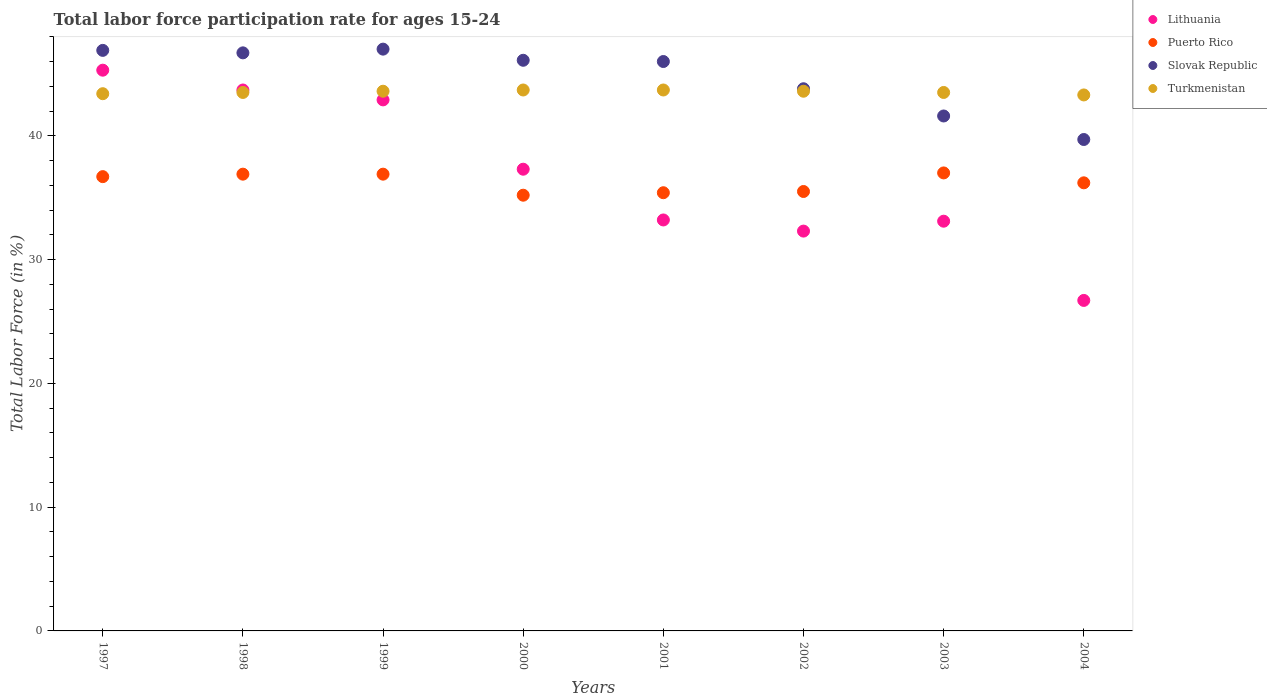Is the number of dotlines equal to the number of legend labels?
Your answer should be compact. Yes. What is the labor force participation rate in Lithuania in 2002?
Your response must be concise. 32.3. Across all years, what is the maximum labor force participation rate in Slovak Republic?
Your response must be concise. 47. Across all years, what is the minimum labor force participation rate in Puerto Rico?
Provide a short and direct response. 35.2. What is the total labor force participation rate in Lithuania in the graph?
Your response must be concise. 294.5. What is the difference between the labor force participation rate in Puerto Rico in 2000 and that in 2001?
Keep it short and to the point. -0.2. What is the average labor force participation rate in Slovak Republic per year?
Offer a terse response. 44.72. In the year 2001, what is the difference between the labor force participation rate in Slovak Republic and labor force participation rate in Lithuania?
Make the answer very short. 12.8. In how many years, is the labor force participation rate in Puerto Rico greater than 30 %?
Give a very brief answer. 8. What is the ratio of the labor force participation rate in Turkmenistan in 1997 to that in 2003?
Make the answer very short. 1. Is the labor force participation rate in Turkmenistan in 1999 less than that in 2002?
Your answer should be very brief. No. Is the difference between the labor force participation rate in Slovak Republic in 2002 and 2004 greater than the difference between the labor force participation rate in Lithuania in 2002 and 2004?
Provide a succinct answer. No. What is the difference between the highest and the second highest labor force participation rate in Puerto Rico?
Your response must be concise. 0.1. What is the difference between the highest and the lowest labor force participation rate in Lithuania?
Offer a very short reply. 18.6. Is the sum of the labor force participation rate in Puerto Rico in 1997 and 1999 greater than the maximum labor force participation rate in Lithuania across all years?
Your response must be concise. Yes. Is it the case that in every year, the sum of the labor force participation rate in Turkmenistan and labor force participation rate in Puerto Rico  is greater than the labor force participation rate in Lithuania?
Keep it short and to the point. Yes. Does the labor force participation rate in Slovak Republic monotonically increase over the years?
Ensure brevity in your answer.  No. Is the labor force participation rate in Slovak Republic strictly greater than the labor force participation rate in Puerto Rico over the years?
Your answer should be very brief. Yes. Is the labor force participation rate in Puerto Rico strictly less than the labor force participation rate in Turkmenistan over the years?
Provide a short and direct response. Yes. How many dotlines are there?
Make the answer very short. 4. Are the values on the major ticks of Y-axis written in scientific E-notation?
Make the answer very short. No. Does the graph contain any zero values?
Provide a succinct answer. No. How are the legend labels stacked?
Your response must be concise. Vertical. What is the title of the graph?
Keep it short and to the point. Total labor force participation rate for ages 15-24. Does "Georgia" appear as one of the legend labels in the graph?
Provide a short and direct response. No. What is the label or title of the Y-axis?
Provide a short and direct response. Total Labor Force (in %). What is the Total Labor Force (in %) of Lithuania in 1997?
Keep it short and to the point. 45.3. What is the Total Labor Force (in %) of Puerto Rico in 1997?
Offer a very short reply. 36.7. What is the Total Labor Force (in %) in Slovak Republic in 1997?
Offer a very short reply. 46.9. What is the Total Labor Force (in %) in Turkmenistan in 1997?
Offer a terse response. 43.4. What is the Total Labor Force (in %) in Lithuania in 1998?
Provide a short and direct response. 43.7. What is the Total Labor Force (in %) of Puerto Rico in 1998?
Offer a terse response. 36.9. What is the Total Labor Force (in %) of Slovak Republic in 1998?
Ensure brevity in your answer.  46.7. What is the Total Labor Force (in %) in Turkmenistan in 1998?
Your answer should be very brief. 43.5. What is the Total Labor Force (in %) of Lithuania in 1999?
Keep it short and to the point. 42.9. What is the Total Labor Force (in %) in Puerto Rico in 1999?
Offer a very short reply. 36.9. What is the Total Labor Force (in %) in Slovak Republic in 1999?
Your answer should be very brief. 47. What is the Total Labor Force (in %) of Turkmenistan in 1999?
Make the answer very short. 43.6. What is the Total Labor Force (in %) in Lithuania in 2000?
Give a very brief answer. 37.3. What is the Total Labor Force (in %) in Puerto Rico in 2000?
Provide a succinct answer. 35.2. What is the Total Labor Force (in %) in Slovak Republic in 2000?
Provide a succinct answer. 46.1. What is the Total Labor Force (in %) of Turkmenistan in 2000?
Offer a very short reply. 43.7. What is the Total Labor Force (in %) of Lithuania in 2001?
Your answer should be compact. 33.2. What is the Total Labor Force (in %) of Puerto Rico in 2001?
Ensure brevity in your answer.  35.4. What is the Total Labor Force (in %) in Slovak Republic in 2001?
Offer a terse response. 46. What is the Total Labor Force (in %) of Turkmenistan in 2001?
Your response must be concise. 43.7. What is the Total Labor Force (in %) in Lithuania in 2002?
Make the answer very short. 32.3. What is the Total Labor Force (in %) in Puerto Rico in 2002?
Keep it short and to the point. 35.5. What is the Total Labor Force (in %) of Slovak Republic in 2002?
Provide a succinct answer. 43.8. What is the Total Labor Force (in %) in Turkmenistan in 2002?
Offer a terse response. 43.6. What is the Total Labor Force (in %) in Lithuania in 2003?
Your answer should be compact. 33.1. What is the Total Labor Force (in %) of Puerto Rico in 2003?
Offer a terse response. 37. What is the Total Labor Force (in %) in Slovak Republic in 2003?
Offer a very short reply. 41.6. What is the Total Labor Force (in %) in Turkmenistan in 2003?
Ensure brevity in your answer.  43.5. What is the Total Labor Force (in %) in Lithuania in 2004?
Ensure brevity in your answer.  26.7. What is the Total Labor Force (in %) of Puerto Rico in 2004?
Ensure brevity in your answer.  36.2. What is the Total Labor Force (in %) in Slovak Republic in 2004?
Ensure brevity in your answer.  39.7. What is the Total Labor Force (in %) of Turkmenistan in 2004?
Provide a short and direct response. 43.3. Across all years, what is the maximum Total Labor Force (in %) of Lithuania?
Ensure brevity in your answer.  45.3. Across all years, what is the maximum Total Labor Force (in %) of Slovak Republic?
Ensure brevity in your answer.  47. Across all years, what is the maximum Total Labor Force (in %) of Turkmenistan?
Offer a very short reply. 43.7. Across all years, what is the minimum Total Labor Force (in %) in Lithuania?
Ensure brevity in your answer.  26.7. Across all years, what is the minimum Total Labor Force (in %) of Puerto Rico?
Offer a terse response. 35.2. Across all years, what is the minimum Total Labor Force (in %) of Slovak Republic?
Give a very brief answer. 39.7. Across all years, what is the minimum Total Labor Force (in %) of Turkmenistan?
Provide a short and direct response. 43.3. What is the total Total Labor Force (in %) in Lithuania in the graph?
Provide a succinct answer. 294.5. What is the total Total Labor Force (in %) in Puerto Rico in the graph?
Your answer should be very brief. 289.8. What is the total Total Labor Force (in %) in Slovak Republic in the graph?
Ensure brevity in your answer.  357.8. What is the total Total Labor Force (in %) of Turkmenistan in the graph?
Make the answer very short. 348.3. What is the difference between the Total Labor Force (in %) in Lithuania in 1997 and that in 1998?
Your answer should be compact. 1.6. What is the difference between the Total Labor Force (in %) in Slovak Republic in 1997 and that in 1998?
Provide a short and direct response. 0.2. What is the difference between the Total Labor Force (in %) of Lithuania in 1997 and that in 1999?
Give a very brief answer. 2.4. What is the difference between the Total Labor Force (in %) in Puerto Rico in 1997 and that in 1999?
Keep it short and to the point. -0.2. What is the difference between the Total Labor Force (in %) in Lithuania in 1997 and that in 2000?
Your response must be concise. 8. What is the difference between the Total Labor Force (in %) in Puerto Rico in 1997 and that in 2000?
Give a very brief answer. 1.5. What is the difference between the Total Labor Force (in %) of Turkmenistan in 1997 and that in 2000?
Offer a very short reply. -0.3. What is the difference between the Total Labor Force (in %) of Slovak Republic in 1997 and that in 2001?
Ensure brevity in your answer.  0.9. What is the difference between the Total Labor Force (in %) in Slovak Republic in 1997 and that in 2002?
Provide a short and direct response. 3.1. What is the difference between the Total Labor Force (in %) of Lithuania in 1997 and that in 2003?
Provide a short and direct response. 12.2. What is the difference between the Total Labor Force (in %) of Slovak Republic in 1997 and that in 2003?
Keep it short and to the point. 5.3. What is the difference between the Total Labor Force (in %) of Turkmenistan in 1997 and that in 2003?
Make the answer very short. -0.1. What is the difference between the Total Labor Force (in %) in Puerto Rico in 1997 and that in 2004?
Your answer should be very brief. 0.5. What is the difference between the Total Labor Force (in %) in Puerto Rico in 1998 and that in 1999?
Your answer should be compact. 0. What is the difference between the Total Labor Force (in %) of Slovak Republic in 1998 and that in 2000?
Your answer should be very brief. 0.6. What is the difference between the Total Labor Force (in %) of Turkmenistan in 1998 and that in 2001?
Offer a very short reply. -0.2. What is the difference between the Total Labor Force (in %) in Slovak Republic in 1998 and that in 2002?
Your answer should be compact. 2.9. What is the difference between the Total Labor Force (in %) of Puerto Rico in 1998 and that in 2003?
Make the answer very short. -0.1. What is the difference between the Total Labor Force (in %) of Slovak Republic in 1998 and that in 2003?
Make the answer very short. 5.1. What is the difference between the Total Labor Force (in %) of Lithuania in 1998 and that in 2004?
Provide a short and direct response. 17. What is the difference between the Total Labor Force (in %) of Slovak Republic in 1998 and that in 2004?
Ensure brevity in your answer.  7. What is the difference between the Total Labor Force (in %) in Turkmenistan in 1998 and that in 2004?
Provide a short and direct response. 0.2. What is the difference between the Total Labor Force (in %) of Puerto Rico in 1999 and that in 2000?
Provide a short and direct response. 1.7. What is the difference between the Total Labor Force (in %) of Slovak Republic in 1999 and that in 2000?
Your response must be concise. 0.9. What is the difference between the Total Labor Force (in %) of Puerto Rico in 1999 and that in 2001?
Offer a very short reply. 1.5. What is the difference between the Total Labor Force (in %) of Puerto Rico in 1999 and that in 2002?
Ensure brevity in your answer.  1.4. What is the difference between the Total Labor Force (in %) of Slovak Republic in 1999 and that in 2002?
Your answer should be very brief. 3.2. What is the difference between the Total Labor Force (in %) in Turkmenistan in 1999 and that in 2002?
Provide a short and direct response. 0. What is the difference between the Total Labor Force (in %) in Lithuania in 1999 and that in 2004?
Offer a very short reply. 16.2. What is the difference between the Total Labor Force (in %) of Turkmenistan in 2000 and that in 2001?
Your answer should be compact. 0. What is the difference between the Total Labor Force (in %) of Lithuania in 2000 and that in 2003?
Offer a very short reply. 4.2. What is the difference between the Total Labor Force (in %) in Slovak Republic in 2000 and that in 2003?
Offer a terse response. 4.5. What is the difference between the Total Labor Force (in %) of Turkmenistan in 2000 and that in 2003?
Your answer should be very brief. 0.2. What is the difference between the Total Labor Force (in %) of Slovak Republic in 2000 and that in 2004?
Offer a very short reply. 6.4. What is the difference between the Total Labor Force (in %) of Puerto Rico in 2001 and that in 2002?
Give a very brief answer. -0.1. What is the difference between the Total Labor Force (in %) of Slovak Republic in 2001 and that in 2002?
Offer a terse response. 2.2. What is the difference between the Total Labor Force (in %) in Turkmenistan in 2001 and that in 2002?
Offer a very short reply. 0.1. What is the difference between the Total Labor Force (in %) of Turkmenistan in 2001 and that in 2003?
Your answer should be very brief. 0.2. What is the difference between the Total Labor Force (in %) of Lithuania in 2001 and that in 2004?
Keep it short and to the point. 6.5. What is the difference between the Total Labor Force (in %) in Turkmenistan in 2001 and that in 2004?
Your answer should be very brief. 0.4. What is the difference between the Total Labor Force (in %) in Slovak Republic in 2002 and that in 2004?
Offer a terse response. 4.1. What is the difference between the Total Labor Force (in %) in Turkmenistan in 2002 and that in 2004?
Provide a succinct answer. 0.3. What is the difference between the Total Labor Force (in %) in Lithuania in 2003 and that in 2004?
Offer a very short reply. 6.4. What is the difference between the Total Labor Force (in %) of Slovak Republic in 2003 and that in 2004?
Keep it short and to the point. 1.9. What is the difference between the Total Labor Force (in %) in Turkmenistan in 2003 and that in 2004?
Offer a terse response. 0.2. What is the difference between the Total Labor Force (in %) of Lithuania in 1997 and the Total Labor Force (in %) of Puerto Rico in 1998?
Give a very brief answer. 8.4. What is the difference between the Total Labor Force (in %) of Lithuania in 1997 and the Total Labor Force (in %) of Puerto Rico in 1999?
Offer a terse response. 8.4. What is the difference between the Total Labor Force (in %) in Lithuania in 1997 and the Total Labor Force (in %) in Slovak Republic in 1999?
Ensure brevity in your answer.  -1.7. What is the difference between the Total Labor Force (in %) in Puerto Rico in 1997 and the Total Labor Force (in %) in Turkmenistan in 1999?
Ensure brevity in your answer.  -6.9. What is the difference between the Total Labor Force (in %) of Lithuania in 1997 and the Total Labor Force (in %) of Turkmenistan in 2000?
Your answer should be compact. 1.6. What is the difference between the Total Labor Force (in %) in Puerto Rico in 1997 and the Total Labor Force (in %) in Turkmenistan in 2000?
Make the answer very short. -7. What is the difference between the Total Labor Force (in %) in Slovak Republic in 1997 and the Total Labor Force (in %) in Turkmenistan in 2000?
Keep it short and to the point. 3.2. What is the difference between the Total Labor Force (in %) of Lithuania in 1997 and the Total Labor Force (in %) of Slovak Republic in 2001?
Provide a short and direct response. -0.7. What is the difference between the Total Labor Force (in %) in Lithuania in 1997 and the Total Labor Force (in %) in Turkmenistan in 2001?
Provide a succinct answer. 1.6. What is the difference between the Total Labor Force (in %) in Slovak Republic in 1997 and the Total Labor Force (in %) in Turkmenistan in 2002?
Provide a succinct answer. 3.3. What is the difference between the Total Labor Force (in %) in Lithuania in 1997 and the Total Labor Force (in %) in Puerto Rico in 2003?
Provide a short and direct response. 8.3. What is the difference between the Total Labor Force (in %) of Lithuania in 1997 and the Total Labor Force (in %) of Slovak Republic in 2003?
Ensure brevity in your answer.  3.7. What is the difference between the Total Labor Force (in %) of Puerto Rico in 1997 and the Total Labor Force (in %) of Slovak Republic in 2003?
Provide a succinct answer. -4.9. What is the difference between the Total Labor Force (in %) in Slovak Republic in 1997 and the Total Labor Force (in %) in Turkmenistan in 2003?
Ensure brevity in your answer.  3.4. What is the difference between the Total Labor Force (in %) in Lithuania in 1997 and the Total Labor Force (in %) in Slovak Republic in 2004?
Your answer should be compact. 5.6. What is the difference between the Total Labor Force (in %) of Lithuania in 1997 and the Total Labor Force (in %) of Turkmenistan in 2004?
Your response must be concise. 2. What is the difference between the Total Labor Force (in %) in Slovak Republic in 1997 and the Total Labor Force (in %) in Turkmenistan in 2004?
Ensure brevity in your answer.  3.6. What is the difference between the Total Labor Force (in %) of Lithuania in 1998 and the Total Labor Force (in %) of Puerto Rico in 1999?
Keep it short and to the point. 6.8. What is the difference between the Total Labor Force (in %) of Lithuania in 1998 and the Total Labor Force (in %) of Turkmenistan in 1999?
Keep it short and to the point. 0.1. What is the difference between the Total Labor Force (in %) of Lithuania in 1998 and the Total Labor Force (in %) of Puerto Rico in 2000?
Your answer should be very brief. 8.5. What is the difference between the Total Labor Force (in %) in Lithuania in 1998 and the Total Labor Force (in %) in Turkmenistan in 2000?
Keep it short and to the point. 0. What is the difference between the Total Labor Force (in %) in Puerto Rico in 1998 and the Total Labor Force (in %) in Slovak Republic in 2000?
Give a very brief answer. -9.2. What is the difference between the Total Labor Force (in %) in Puerto Rico in 1998 and the Total Labor Force (in %) in Turkmenistan in 2000?
Offer a very short reply. -6.8. What is the difference between the Total Labor Force (in %) of Slovak Republic in 1998 and the Total Labor Force (in %) of Turkmenistan in 2000?
Your answer should be very brief. 3. What is the difference between the Total Labor Force (in %) of Lithuania in 1998 and the Total Labor Force (in %) of Puerto Rico in 2001?
Provide a succinct answer. 8.3. What is the difference between the Total Labor Force (in %) of Lithuania in 1998 and the Total Labor Force (in %) of Slovak Republic in 2001?
Offer a very short reply. -2.3. What is the difference between the Total Labor Force (in %) of Lithuania in 1998 and the Total Labor Force (in %) of Turkmenistan in 2001?
Your response must be concise. 0. What is the difference between the Total Labor Force (in %) in Lithuania in 1998 and the Total Labor Force (in %) in Puerto Rico in 2002?
Offer a very short reply. 8.2. What is the difference between the Total Labor Force (in %) in Lithuania in 1998 and the Total Labor Force (in %) in Slovak Republic in 2002?
Ensure brevity in your answer.  -0.1. What is the difference between the Total Labor Force (in %) of Puerto Rico in 1998 and the Total Labor Force (in %) of Slovak Republic in 2002?
Provide a succinct answer. -6.9. What is the difference between the Total Labor Force (in %) in Puerto Rico in 1998 and the Total Labor Force (in %) in Turkmenistan in 2002?
Ensure brevity in your answer.  -6.7. What is the difference between the Total Labor Force (in %) in Lithuania in 1998 and the Total Labor Force (in %) in Slovak Republic in 2003?
Offer a very short reply. 2.1. What is the difference between the Total Labor Force (in %) in Puerto Rico in 1998 and the Total Labor Force (in %) in Slovak Republic in 2003?
Offer a terse response. -4.7. What is the difference between the Total Labor Force (in %) of Slovak Republic in 1998 and the Total Labor Force (in %) of Turkmenistan in 2003?
Keep it short and to the point. 3.2. What is the difference between the Total Labor Force (in %) in Lithuania in 1998 and the Total Labor Force (in %) in Turkmenistan in 2004?
Give a very brief answer. 0.4. What is the difference between the Total Labor Force (in %) of Lithuania in 1999 and the Total Labor Force (in %) of Slovak Republic in 2000?
Provide a succinct answer. -3.2. What is the difference between the Total Labor Force (in %) of Lithuania in 1999 and the Total Labor Force (in %) of Turkmenistan in 2000?
Provide a succinct answer. -0.8. What is the difference between the Total Labor Force (in %) in Puerto Rico in 1999 and the Total Labor Force (in %) in Slovak Republic in 2000?
Offer a very short reply. -9.2. What is the difference between the Total Labor Force (in %) in Slovak Republic in 1999 and the Total Labor Force (in %) in Turkmenistan in 2000?
Your answer should be very brief. 3.3. What is the difference between the Total Labor Force (in %) in Lithuania in 1999 and the Total Labor Force (in %) in Puerto Rico in 2001?
Offer a very short reply. 7.5. What is the difference between the Total Labor Force (in %) in Lithuania in 1999 and the Total Labor Force (in %) in Turkmenistan in 2001?
Your answer should be compact. -0.8. What is the difference between the Total Labor Force (in %) in Lithuania in 1999 and the Total Labor Force (in %) in Slovak Republic in 2003?
Offer a very short reply. 1.3. What is the difference between the Total Labor Force (in %) in Puerto Rico in 1999 and the Total Labor Force (in %) in Turkmenistan in 2003?
Provide a succinct answer. -6.6. What is the difference between the Total Labor Force (in %) in Lithuania in 1999 and the Total Labor Force (in %) in Puerto Rico in 2004?
Provide a succinct answer. 6.7. What is the difference between the Total Labor Force (in %) in Lithuania in 1999 and the Total Labor Force (in %) in Slovak Republic in 2004?
Keep it short and to the point. 3.2. What is the difference between the Total Labor Force (in %) in Puerto Rico in 1999 and the Total Labor Force (in %) in Turkmenistan in 2004?
Your answer should be very brief. -6.4. What is the difference between the Total Labor Force (in %) in Lithuania in 2000 and the Total Labor Force (in %) in Slovak Republic in 2001?
Give a very brief answer. -8.7. What is the difference between the Total Labor Force (in %) in Lithuania in 2000 and the Total Labor Force (in %) in Turkmenistan in 2001?
Give a very brief answer. -6.4. What is the difference between the Total Labor Force (in %) of Puerto Rico in 2000 and the Total Labor Force (in %) of Slovak Republic in 2001?
Offer a very short reply. -10.8. What is the difference between the Total Labor Force (in %) of Puerto Rico in 2000 and the Total Labor Force (in %) of Turkmenistan in 2001?
Your answer should be compact. -8.5. What is the difference between the Total Labor Force (in %) in Lithuania in 2000 and the Total Labor Force (in %) in Slovak Republic in 2002?
Keep it short and to the point. -6.5. What is the difference between the Total Labor Force (in %) in Lithuania in 2000 and the Total Labor Force (in %) in Slovak Republic in 2003?
Keep it short and to the point. -4.3. What is the difference between the Total Labor Force (in %) of Slovak Republic in 2000 and the Total Labor Force (in %) of Turkmenistan in 2003?
Provide a succinct answer. 2.6. What is the difference between the Total Labor Force (in %) in Lithuania in 2000 and the Total Labor Force (in %) in Slovak Republic in 2004?
Your response must be concise. -2.4. What is the difference between the Total Labor Force (in %) in Lithuania in 2000 and the Total Labor Force (in %) in Turkmenistan in 2004?
Your answer should be very brief. -6. What is the difference between the Total Labor Force (in %) of Puerto Rico in 2001 and the Total Labor Force (in %) of Turkmenistan in 2002?
Make the answer very short. -8.2. What is the difference between the Total Labor Force (in %) in Slovak Republic in 2001 and the Total Labor Force (in %) in Turkmenistan in 2002?
Give a very brief answer. 2.4. What is the difference between the Total Labor Force (in %) of Puerto Rico in 2001 and the Total Labor Force (in %) of Slovak Republic in 2003?
Provide a short and direct response. -6.2. What is the difference between the Total Labor Force (in %) in Puerto Rico in 2001 and the Total Labor Force (in %) in Turkmenistan in 2003?
Make the answer very short. -8.1. What is the difference between the Total Labor Force (in %) of Slovak Republic in 2001 and the Total Labor Force (in %) of Turkmenistan in 2003?
Your response must be concise. 2.5. What is the difference between the Total Labor Force (in %) of Lithuania in 2001 and the Total Labor Force (in %) of Slovak Republic in 2004?
Make the answer very short. -6.5. What is the difference between the Total Labor Force (in %) of Lithuania in 2001 and the Total Labor Force (in %) of Turkmenistan in 2004?
Ensure brevity in your answer.  -10.1. What is the difference between the Total Labor Force (in %) of Slovak Republic in 2001 and the Total Labor Force (in %) of Turkmenistan in 2004?
Provide a short and direct response. 2.7. What is the difference between the Total Labor Force (in %) of Lithuania in 2002 and the Total Labor Force (in %) of Puerto Rico in 2003?
Provide a succinct answer. -4.7. What is the difference between the Total Labor Force (in %) of Lithuania in 2002 and the Total Labor Force (in %) of Puerto Rico in 2004?
Offer a terse response. -3.9. What is the difference between the Total Labor Force (in %) in Puerto Rico in 2002 and the Total Labor Force (in %) in Slovak Republic in 2004?
Ensure brevity in your answer.  -4.2. What is the difference between the Total Labor Force (in %) of Slovak Republic in 2002 and the Total Labor Force (in %) of Turkmenistan in 2004?
Provide a succinct answer. 0.5. What is the difference between the Total Labor Force (in %) of Lithuania in 2003 and the Total Labor Force (in %) of Puerto Rico in 2004?
Give a very brief answer. -3.1. What is the difference between the Total Labor Force (in %) of Lithuania in 2003 and the Total Labor Force (in %) of Slovak Republic in 2004?
Offer a very short reply. -6.6. What is the difference between the Total Labor Force (in %) in Lithuania in 2003 and the Total Labor Force (in %) in Turkmenistan in 2004?
Your answer should be very brief. -10.2. What is the difference between the Total Labor Force (in %) of Puerto Rico in 2003 and the Total Labor Force (in %) of Slovak Republic in 2004?
Your answer should be very brief. -2.7. What is the difference between the Total Labor Force (in %) in Puerto Rico in 2003 and the Total Labor Force (in %) in Turkmenistan in 2004?
Provide a succinct answer. -6.3. What is the difference between the Total Labor Force (in %) in Slovak Republic in 2003 and the Total Labor Force (in %) in Turkmenistan in 2004?
Keep it short and to the point. -1.7. What is the average Total Labor Force (in %) in Lithuania per year?
Offer a terse response. 36.81. What is the average Total Labor Force (in %) of Puerto Rico per year?
Give a very brief answer. 36.23. What is the average Total Labor Force (in %) in Slovak Republic per year?
Keep it short and to the point. 44.73. What is the average Total Labor Force (in %) in Turkmenistan per year?
Your answer should be compact. 43.54. In the year 1997, what is the difference between the Total Labor Force (in %) of Lithuania and Total Labor Force (in %) of Puerto Rico?
Your response must be concise. 8.6. In the year 1997, what is the difference between the Total Labor Force (in %) in Lithuania and Total Labor Force (in %) in Slovak Republic?
Your response must be concise. -1.6. In the year 1998, what is the difference between the Total Labor Force (in %) in Lithuania and Total Labor Force (in %) in Puerto Rico?
Provide a short and direct response. 6.8. In the year 1998, what is the difference between the Total Labor Force (in %) in Lithuania and Total Labor Force (in %) in Turkmenistan?
Offer a very short reply. 0.2. In the year 1998, what is the difference between the Total Labor Force (in %) of Puerto Rico and Total Labor Force (in %) of Turkmenistan?
Offer a very short reply. -6.6. In the year 1998, what is the difference between the Total Labor Force (in %) in Slovak Republic and Total Labor Force (in %) in Turkmenistan?
Your answer should be very brief. 3.2. In the year 1999, what is the difference between the Total Labor Force (in %) of Lithuania and Total Labor Force (in %) of Turkmenistan?
Your response must be concise. -0.7. In the year 1999, what is the difference between the Total Labor Force (in %) in Puerto Rico and Total Labor Force (in %) in Slovak Republic?
Provide a succinct answer. -10.1. In the year 1999, what is the difference between the Total Labor Force (in %) of Puerto Rico and Total Labor Force (in %) of Turkmenistan?
Provide a short and direct response. -6.7. In the year 2000, what is the difference between the Total Labor Force (in %) in Lithuania and Total Labor Force (in %) in Puerto Rico?
Make the answer very short. 2.1. In the year 2000, what is the difference between the Total Labor Force (in %) of Lithuania and Total Labor Force (in %) of Slovak Republic?
Your response must be concise. -8.8. In the year 2000, what is the difference between the Total Labor Force (in %) in Puerto Rico and Total Labor Force (in %) in Slovak Republic?
Offer a terse response. -10.9. In the year 2000, what is the difference between the Total Labor Force (in %) in Slovak Republic and Total Labor Force (in %) in Turkmenistan?
Provide a short and direct response. 2.4. In the year 2001, what is the difference between the Total Labor Force (in %) in Lithuania and Total Labor Force (in %) in Slovak Republic?
Make the answer very short. -12.8. In the year 2001, what is the difference between the Total Labor Force (in %) in Lithuania and Total Labor Force (in %) in Turkmenistan?
Your response must be concise. -10.5. In the year 2001, what is the difference between the Total Labor Force (in %) of Puerto Rico and Total Labor Force (in %) of Slovak Republic?
Provide a short and direct response. -10.6. In the year 2002, what is the difference between the Total Labor Force (in %) of Lithuania and Total Labor Force (in %) of Puerto Rico?
Keep it short and to the point. -3.2. In the year 2002, what is the difference between the Total Labor Force (in %) in Slovak Republic and Total Labor Force (in %) in Turkmenistan?
Provide a succinct answer. 0.2. In the year 2003, what is the difference between the Total Labor Force (in %) of Lithuania and Total Labor Force (in %) of Puerto Rico?
Give a very brief answer. -3.9. In the year 2003, what is the difference between the Total Labor Force (in %) in Lithuania and Total Labor Force (in %) in Slovak Republic?
Your response must be concise. -8.5. In the year 2003, what is the difference between the Total Labor Force (in %) in Lithuania and Total Labor Force (in %) in Turkmenistan?
Ensure brevity in your answer.  -10.4. In the year 2003, what is the difference between the Total Labor Force (in %) in Puerto Rico and Total Labor Force (in %) in Slovak Republic?
Your answer should be compact. -4.6. In the year 2003, what is the difference between the Total Labor Force (in %) in Slovak Republic and Total Labor Force (in %) in Turkmenistan?
Provide a short and direct response. -1.9. In the year 2004, what is the difference between the Total Labor Force (in %) in Lithuania and Total Labor Force (in %) in Slovak Republic?
Your answer should be compact. -13. In the year 2004, what is the difference between the Total Labor Force (in %) of Lithuania and Total Labor Force (in %) of Turkmenistan?
Provide a succinct answer. -16.6. In the year 2004, what is the difference between the Total Labor Force (in %) in Puerto Rico and Total Labor Force (in %) in Turkmenistan?
Your answer should be compact. -7.1. What is the ratio of the Total Labor Force (in %) in Lithuania in 1997 to that in 1998?
Your answer should be compact. 1.04. What is the ratio of the Total Labor Force (in %) in Slovak Republic in 1997 to that in 1998?
Make the answer very short. 1. What is the ratio of the Total Labor Force (in %) in Turkmenistan in 1997 to that in 1998?
Provide a succinct answer. 1. What is the ratio of the Total Labor Force (in %) in Lithuania in 1997 to that in 1999?
Your answer should be very brief. 1.06. What is the ratio of the Total Labor Force (in %) of Turkmenistan in 1997 to that in 1999?
Provide a succinct answer. 1. What is the ratio of the Total Labor Force (in %) of Lithuania in 1997 to that in 2000?
Make the answer very short. 1.21. What is the ratio of the Total Labor Force (in %) of Puerto Rico in 1997 to that in 2000?
Offer a very short reply. 1.04. What is the ratio of the Total Labor Force (in %) of Slovak Republic in 1997 to that in 2000?
Provide a short and direct response. 1.02. What is the ratio of the Total Labor Force (in %) of Lithuania in 1997 to that in 2001?
Provide a short and direct response. 1.36. What is the ratio of the Total Labor Force (in %) in Puerto Rico in 1997 to that in 2001?
Your response must be concise. 1.04. What is the ratio of the Total Labor Force (in %) of Slovak Republic in 1997 to that in 2001?
Provide a succinct answer. 1.02. What is the ratio of the Total Labor Force (in %) of Turkmenistan in 1997 to that in 2001?
Make the answer very short. 0.99. What is the ratio of the Total Labor Force (in %) in Lithuania in 1997 to that in 2002?
Your answer should be compact. 1.4. What is the ratio of the Total Labor Force (in %) in Puerto Rico in 1997 to that in 2002?
Your response must be concise. 1.03. What is the ratio of the Total Labor Force (in %) of Slovak Republic in 1997 to that in 2002?
Ensure brevity in your answer.  1.07. What is the ratio of the Total Labor Force (in %) in Turkmenistan in 1997 to that in 2002?
Your answer should be very brief. 1. What is the ratio of the Total Labor Force (in %) in Lithuania in 1997 to that in 2003?
Offer a very short reply. 1.37. What is the ratio of the Total Labor Force (in %) of Puerto Rico in 1997 to that in 2003?
Provide a short and direct response. 0.99. What is the ratio of the Total Labor Force (in %) of Slovak Republic in 1997 to that in 2003?
Your answer should be very brief. 1.13. What is the ratio of the Total Labor Force (in %) in Lithuania in 1997 to that in 2004?
Offer a terse response. 1.7. What is the ratio of the Total Labor Force (in %) of Puerto Rico in 1997 to that in 2004?
Ensure brevity in your answer.  1.01. What is the ratio of the Total Labor Force (in %) of Slovak Republic in 1997 to that in 2004?
Give a very brief answer. 1.18. What is the ratio of the Total Labor Force (in %) in Lithuania in 1998 to that in 1999?
Your response must be concise. 1.02. What is the ratio of the Total Labor Force (in %) of Puerto Rico in 1998 to that in 1999?
Your answer should be compact. 1. What is the ratio of the Total Labor Force (in %) of Lithuania in 1998 to that in 2000?
Your answer should be very brief. 1.17. What is the ratio of the Total Labor Force (in %) of Puerto Rico in 1998 to that in 2000?
Give a very brief answer. 1.05. What is the ratio of the Total Labor Force (in %) in Lithuania in 1998 to that in 2001?
Make the answer very short. 1.32. What is the ratio of the Total Labor Force (in %) of Puerto Rico in 1998 to that in 2001?
Offer a terse response. 1.04. What is the ratio of the Total Labor Force (in %) in Slovak Republic in 1998 to that in 2001?
Your response must be concise. 1.02. What is the ratio of the Total Labor Force (in %) in Turkmenistan in 1998 to that in 2001?
Provide a succinct answer. 1. What is the ratio of the Total Labor Force (in %) in Lithuania in 1998 to that in 2002?
Make the answer very short. 1.35. What is the ratio of the Total Labor Force (in %) in Puerto Rico in 1998 to that in 2002?
Make the answer very short. 1.04. What is the ratio of the Total Labor Force (in %) of Slovak Republic in 1998 to that in 2002?
Give a very brief answer. 1.07. What is the ratio of the Total Labor Force (in %) of Lithuania in 1998 to that in 2003?
Your answer should be compact. 1.32. What is the ratio of the Total Labor Force (in %) in Puerto Rico in 1998 to that in 2003?
Ensure brevity in your answer.  1. What is the ratio of the Total Labor Force (in %) of Slovak Republic in 1998 to that in 2003?
Your response must be concise. 1.12. What is the ratio of the Total Labor Force (in %) in Turkmenistan in 1998 to that in 2003?
Ensure brevity in your answer.  1. What is the ratio of the Total Labor Force (in %) of Lithuania in 1998 to that in 2004?
Provide a succinct answer. 1.64. What is the ratio of the Total Labor Force (in %) in Puerto Rico in 1998 to that in 2004?
Make the answer very short. 1.02. What is the ratio of the Total Labor Force (in %) of Slovak Republic in 1998 to that in 2004?
Your answer should be compact. 1.18. What is the ratio of the Total Labor Force (in %) in Lithuania in 1999 to that in 2000?
Give a very brief answer. 1.15. What is the ratio of the Total Labor Force (in %) in Puerto Rico in 1999 to that in 2000?
Give a very brief answer. 1.05. What is the ratio of the Total Labor Force (in %) in Slovak Republic in 1999 to that in 2000?
Ensure brevity in your answer.  1.02. What is the ratio of the Total Labor Force (in %) of Turkmenistan in 1999 to that in 2000?
Provide a short and direct response. 1. What is the ratio of the Total Labor Force (in %) of Lithuania in 1999 to that in 2001?
Give a very brief answer. 1.29. What is the ratio of the Total Labor Force (in %) in Puerto Rico in 1999 to that in 2001?
Give a very brief answer. 1.04. What is the ratio of the Total Labor Force (in %) of Slovak Republic in 1999 to that in 2001?
Provide a succinct answer. 1.02. What is the ratio of the Total Labor Force (in %) of Lithuania in 1999 to that in 2002?
Your answer should be compact. 1.33. What is the ratio of the Total Labor Force (in %) of Puerto Rico in 1999 to that in 2002?
Your answer should be compact. 1.04. What is the ratio of the Total Labor Force (in %) in Slovak Republic in 1999 to that in 2002?
Give a very brief answer. 1.07. What is the ratio of the Total Labor Force (in %) in Turkmenistan in 1999 to that in 2002?
Give a very brief answer. 1. What is the ratio of the Total Labor Force (in %) of Lithuania in 1999 to that in 2003?
Make the answer very short. 1.3. What is the ratio of the Total Labor Force (in %) in Slovak Republic in 1999 to that in 2003?
Offer a very short reply. 1.13. What is the ratio of the Total Labor Force (in %) of Lithuania in 1999 to that in 2004?
Ensure brevity in your answer.  1.61. What is the ratio of the Total Labor Force (in %) of Puerto Rico in 1999 to that in 2004?
Ensure brevity in your answer.  1.02. What is the ratio of the Total Labor Force (in %) in Slovak Republic in 1999 to that in 2004?
Make the answer very short. 1.18. What is the ratio of the Total Labor Force (in %) in Lithuania in 2000 to that in 2001?
Your answer should be very brief. 1.12. What is the ratio of the Total Labor Force (in %) of Slovak Republic in 2000 to that in 2001?
Ensure brevity in your answer.  1. What is the ratio of the Total Labor Force (in %) of Turkmenistan in 2000 to that in 2001?
Offer a terse response. 1. What is the ratio of the Total Labor Force (in %) in Lithuania in 2000 to that in 2002?
Provide a short and direct response. 1.15. What is the ratio of the Total Labor Force (in %) of Slovak Republic in 2000 to that in 2002?
Offer a terse response. 1.05. What is the ratio of the Total Labor Force (in %) in Lithuania in 2000 to that in 2003?
Provide a succinct answer. 1.13. What is the ratio of the Total Labor Force (in %) of Puerto Rico in 2000 to that in 2003?
Your response must be concise. 0.95. What is the ratio of the Total Labor Force (in %) of Slovak Republic in 2000 to that in 2003?
Provide a succinct answer. 1.11. What is the ratio of the Total Labor Force (in %) of Turkmenistan in 2000 to that in 2003?
Your answer should be compact. 1. What is the ratio of the Total Labor Force (in %) in Lithuania in 2000 to that in 2004?
Your response must be concise. 1.4. What is the ratio of the Total Labor Force (in %) in Puerto Rico in 2000 to that in 2004?
Your response must be concise. 0.97. What is the ratio of the Total Labor Force (in %) in Slovak Republic in 2000 to that in 2004?
Keep it short and to the point. 1.16. What is the ratio of the Total Labor Force (in %) in Turkmenistan in 2000 to that in 2004?
Offer a terse response. 1.01. What is the ratio of the Total Labor Force (in %) of Lithuania in 2001 to that in 2002?
Your response must be concise. 1.03. What is the ratio of the Total Labor Force (in %) in Puerto Rico in 2001 to that in 2002?
Keep it short and to the point. 1. What is the ratio of the Total Labor Force (in %) of Slovak Republic in 2001 to that in 2002?
Keep it short and to the point. 1.05. What is the ratio of the Total Labor Force (in %) of Lithuania in 2001 to that in 2003?
Your response must be concise. 1. What is the ratio of the Total Labor Force (in %) of Puerto Rico in 2001 to that in 2003?
Your response must be concise. 0.96. What is the ratio of the Total Labor Force (in %) of Slovak Republic in 2001 to that in 2003?
Your response must be concise. 1.11. What is the ratio of the Total Labor Force (in %) in Lithuania in 2001 to that in 2004?
Your answer should be very brief. 1.24. What is the ratio of the Total Labor Force (in %) of Puerto Rico in 2001 to that in 2004?
Your response must be concise. 0.98. What is the ratio of the Total Labor Force (in %) in Slovak Republic in 2001 to that in 2004?
Your answer should be compact. 1.16. What is the ratio of the Total Labor Force (in %) of Turkmenistan in 2001 to that in 2004?
Offer a very short reply. 1.01. What is the ratio of the Total Labor Force (in %) of Lithuania in 2002 to that in 2003?
Your response must be concise. 0.98. What is the ratio of the Total Labor Force (in %) of Puerto Rico in 2002 to that in 2003?
Keep it short and to the point. 0.96. What is the ratio of the Total Labor Force (in %) in Slovak Republic in 2002 to that in 2003?
Your answer should be compact. 1.05. What is the ratio of the Total Labor Force (in %) in Turkmenistan in 2002 to that in 2003?
Offer a terse response. 1. What is the ratio of the Total Labor Force (in %) in Lithuania in 2002 to that in 2004?
Provide a short and direct response. 1.21. What is the ratio of the Total Labor Force (in %) of Puerto Rico in 2002 to that in 2004?
Make the answer very short. 0.98. What is the ratio of the Total Labor Force (in %) in Slovak Republic in 2002 to that in 2004?
Your answer should be very brief. 1.1. What is the ratio of the Total Labor Force (in %) of Turkmenistan in 2002 to that in 2004?
Make the answer very short. 1.01. What is the ratio of the Total Labor Force (in %) of Lithuania in 2003 to that in 2004?
Your answer should be compact. 1.24. What is the ratio of the Total Labor Force (in %) of Puerto Rico in 2003 to that in 2004?
Make the answer very short. 1.02. What is the ratio of the Total Labor Force (in %) in Slovak Republic in 2003 to that in 2004?
Make the answer very short. 1.05. What is the ratio of the Total Labor Force (in %) in Turkmenistan in 2003 to that in 2004?
Ensure brevity in your answer.  1. What is the difference between the highest and the second highest Total Labor Force (in %) in Puerto Rico?
Give a very brief answer. 0.1. What is the difference between the highest and the second highest Total Labor Force (in %) of Slovak Republic?
Ensure brevity in your answer.  0.1. What is the difference between the highest and the second highest Total Labor Force (in %) of Turkmenistan?
Your answer should be compact. 0. What is the difference between the highest and the lowest Total Labor Force (in %) in Slovak Republic?
Provide a short and direct response. 7.3. What is the difference between the highest and the lowest Total Labor Force (in %) in Turkmenistan?
Provide a short and direct response. 0.4. 